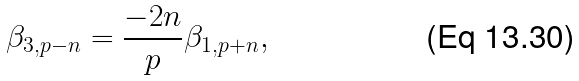<formula> <loc_0><loc_0><loc_500><loc_500>\beta _ { 3 , p - n } = \frac { - 2 n } { p } \beta _ { 1 , p + n } ,</formula> 